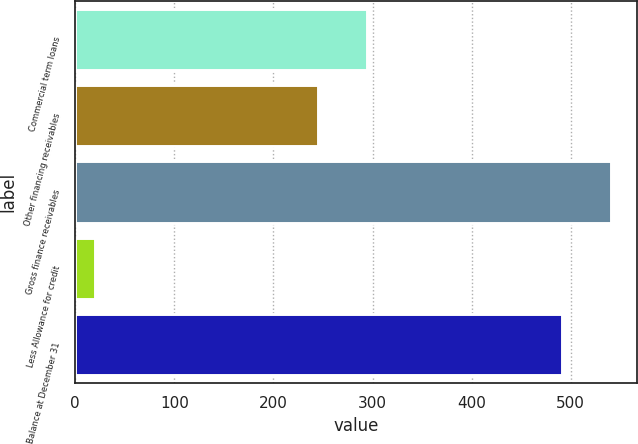Convert chart to OTSL. <chart><loc_0><loc_0><loc_500><loc_500><bar_chart><fcel>Commercial term loans<fcel>Other financing receivables<fcel>Gross finance receivables<fcel>Less Allowance for credit<fcel>Balance at December 31<nl><fcel>294.1<fcel>245<fcel>540.1<fcel>20<fcel>491<nl></chart> 